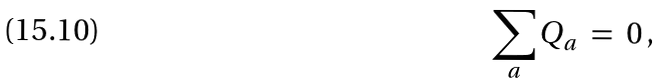Convert formula to latex. <formula><loc_0><loc_0><loc_500><loc_500>\sum _ { a } Q _ { a } \ & = \ 0 \, ,</formula> 